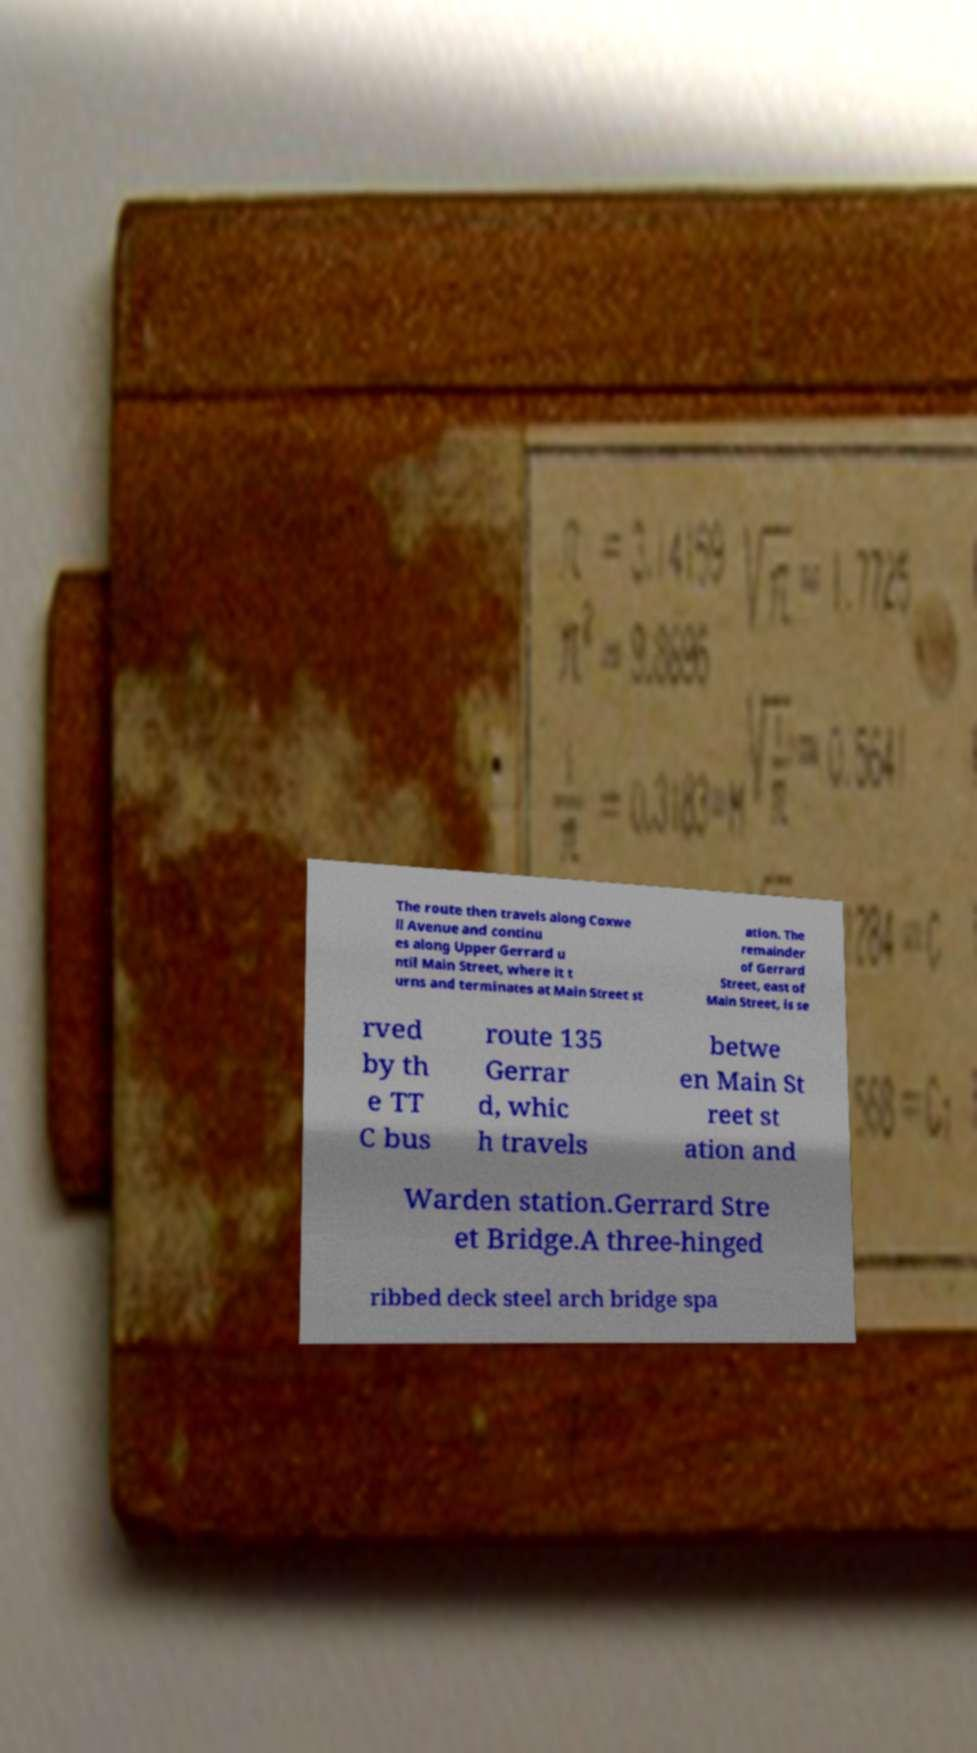Could you extract and type out the text from this image? The route then travels along Coxwe ll Avenue and continu es along Upper Gerrard u ntil Main Street, where it t urns and terminates at Main Street st ation. The remainder of Gerrard Street, east of Main Street, is se rved by th e TT C bus route 135 Gerrar d, whic h travels betwe en Main St reet st ation and Warden station.Gerrard Stre et Bridge.A three-hinged ribbed deck steel arch bridge spa 